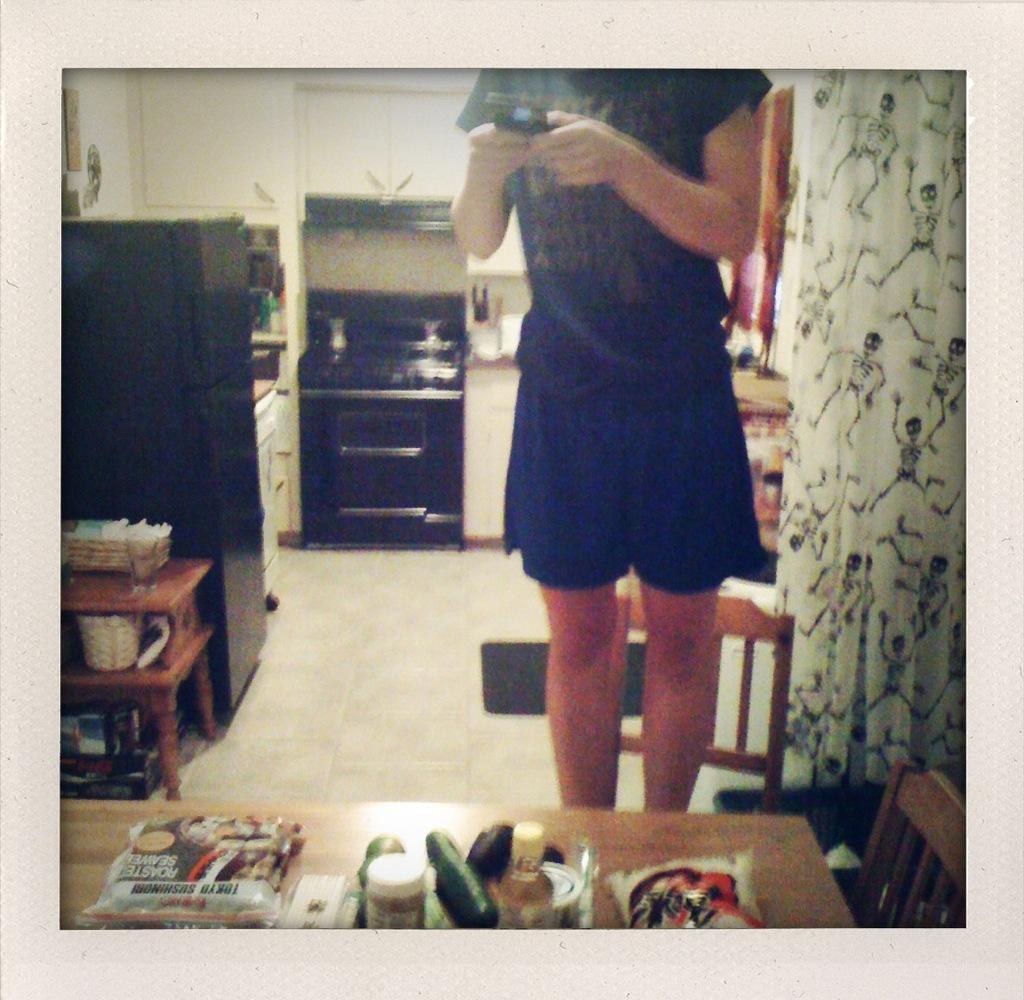Can you describe this image briefly? In the image we can see there is a person standing and she is holding mobile phone in her hand. There is a curtain and there are pictures of the skeletons on the curtain. There are food items kept on the table and there are packets and bottles. Behind there is refrigerator and gas stove. There are baskets kept on the table. 